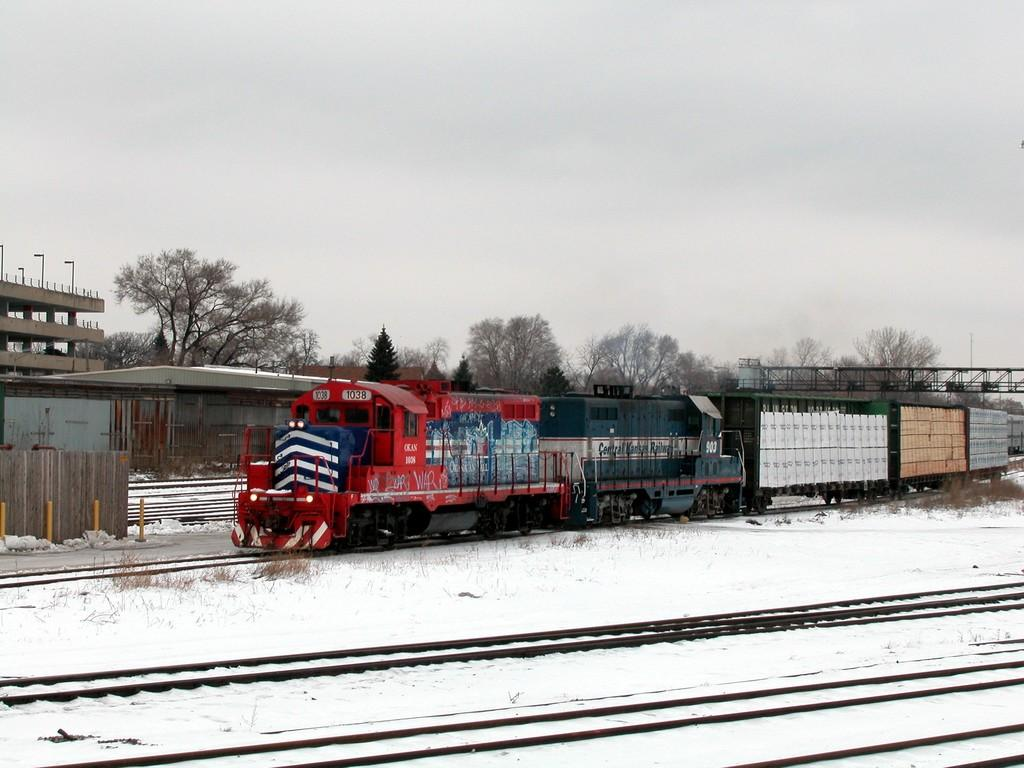What is the main subject of the image? The main subject of the image is a train. Can you describe the train's location in the image? The train is on a track in the image. How is the train visually depicted? The train is colorful in the image. What type of weather is shown in the image? There is snow visible in the image. What can be seen in the background of the image? There is a shed and many trees in the background of the image, as well as the sky. What type of grain is being harvested by the rake in the image? There is no rake or grain present in the image; it features a colorful train on a track with snow in the background. 